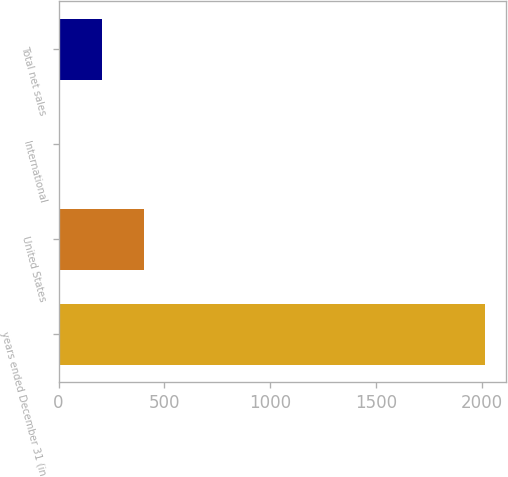Convert chart. <chart><loc_0><loc_0><loc_500><loc_500><bar_chart><fcel>years ended December 31 (in<fcel>United States<fcel>International<fcel>Total net sales<nl><fcel>2012<fcel>405.6<fcel>4<fcel>204.8<nl></chart> 